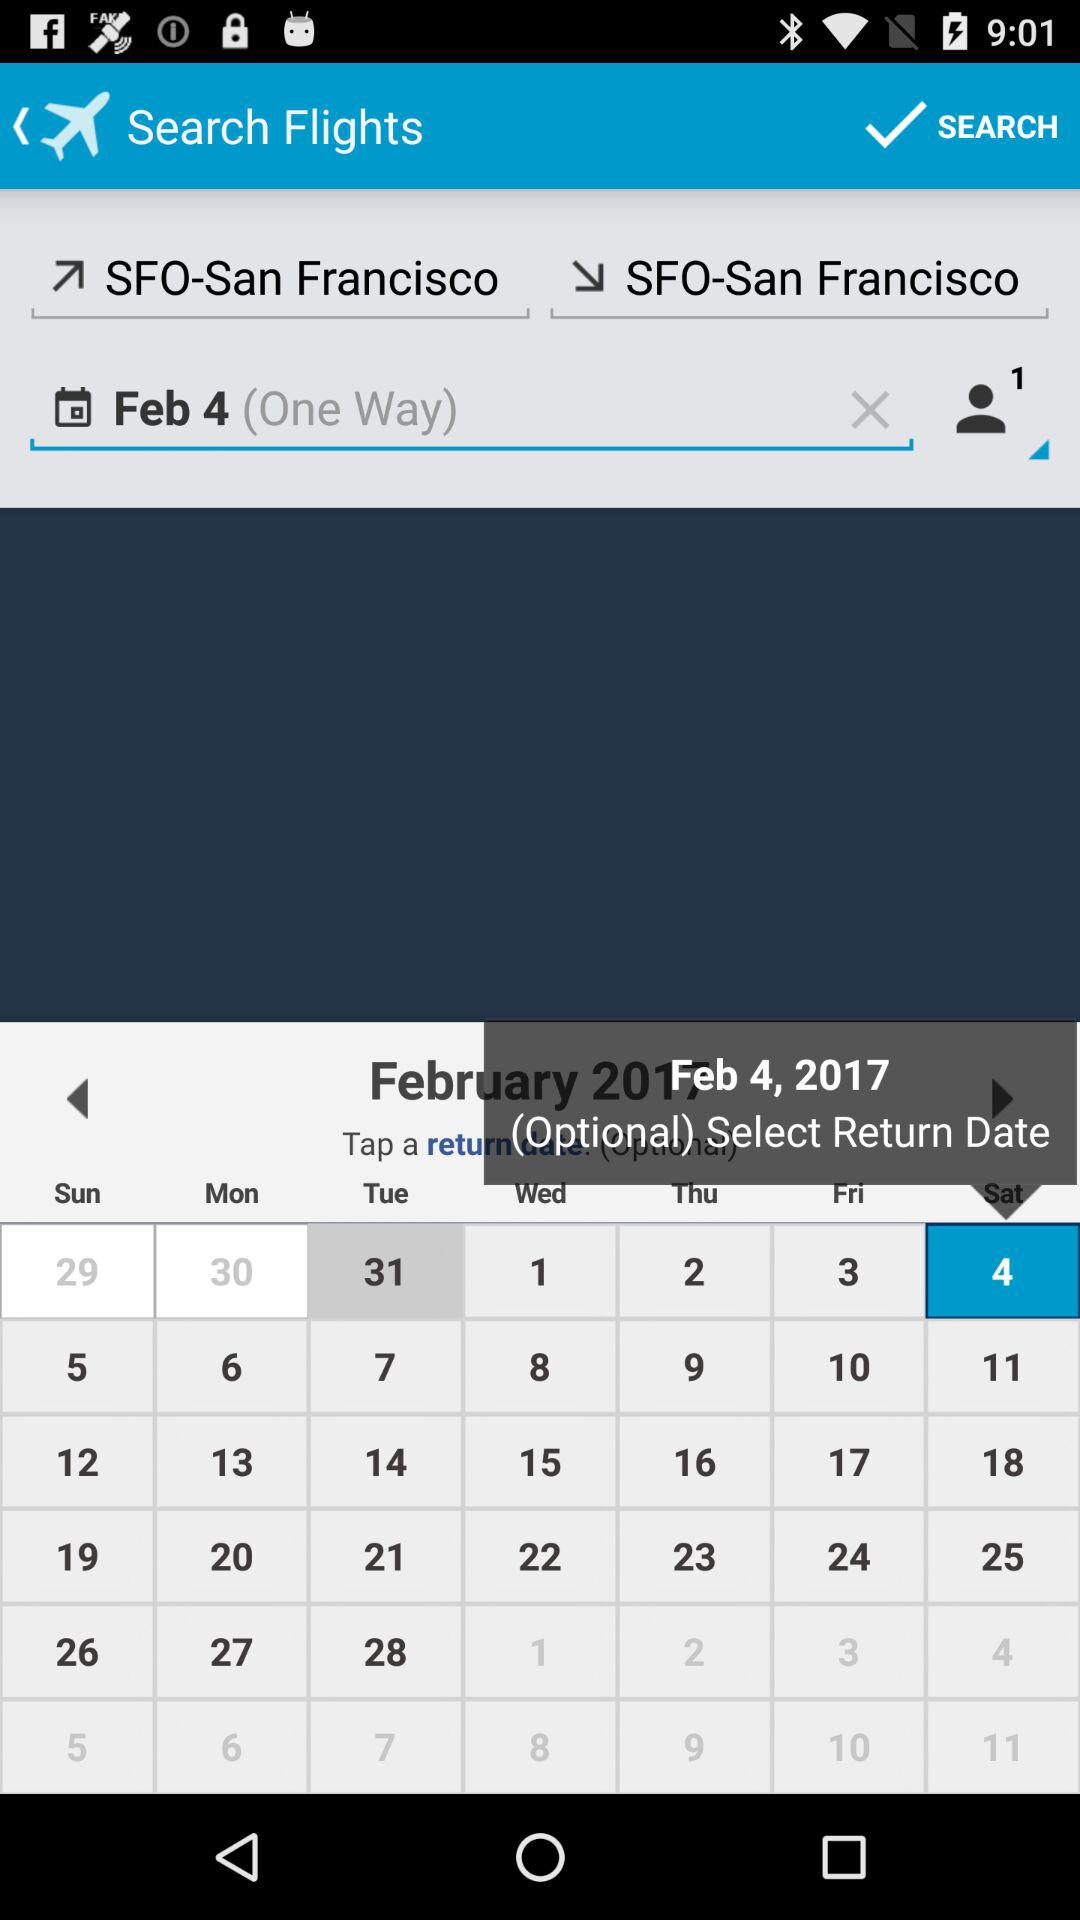What is the scheduled date for the journey? The scheduled date for the journey is February 4, 2017. 